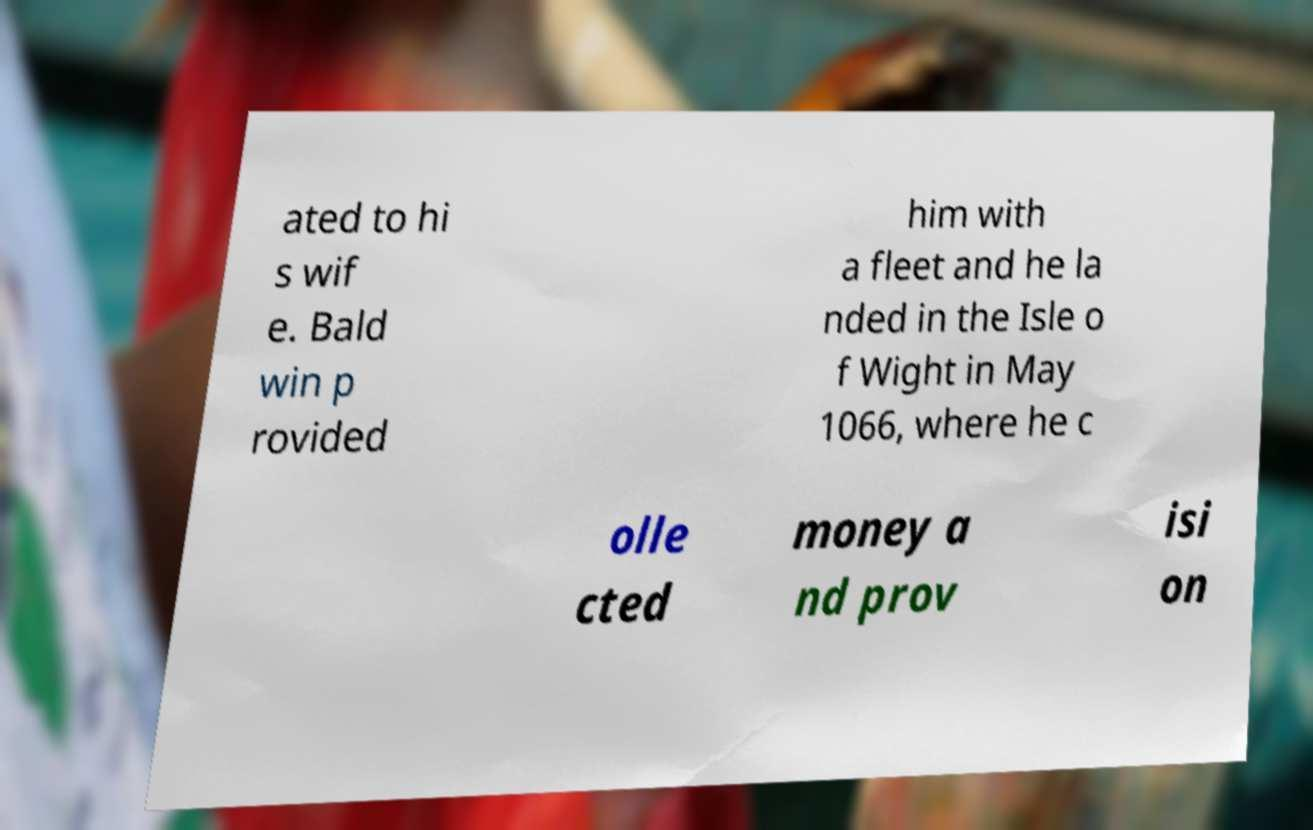Can you read and provide the text displayed in the image?This photo seems to have some interesting text. Can you extract and type it out for me? ated to hi s wif e. Bald win p rovided him with a fleet and he la nded in the Isle o f Wight in May 1066, where he c olle cted money a nd prov isi on 